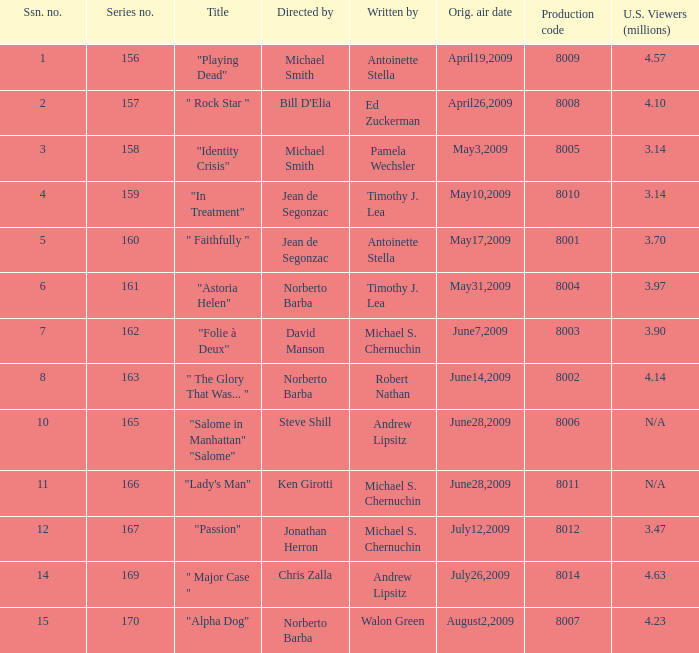Who are the writer of the series episode number 170? Walon Green. 